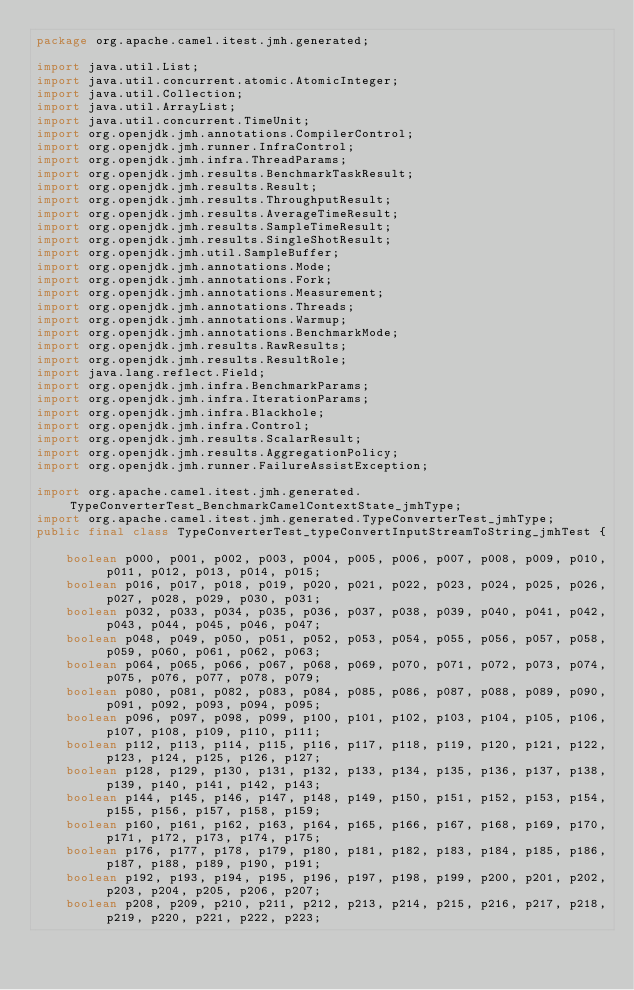Convert code to text. <code><loc_0><loc_0><loc_500><loc_500><_Java_>package org.apache.camel.itest.jmh.generated;

import java.util.List;
import java.util.concurrent.atomic.AtomicInteger;
import java.util.Collection;
import java.util.ArrayList;
import java.util.concurrent.TimeUnit;
import org.openjdk.jmh.annotations.CompilerControl;
import org.openjdk.jmh.runner.InfraControl;
import org.openjdk.jmh.infra.ThreadParams;
import org.openjdk.jmh.results.BenchmarkTaskResult;
import org.openjdk.jmh.results.Result;
import org.openjdk.jmh.results.ThroughputResult;
import org.openjdk.jmh.results.AverageTimeResult;
import org.openjdk.jmh.results.SampleTimeResult;
import org.openjdk.jmh.results.SingleShotResult;
import org.openjdk.jmh.util.SampleBuffer;
import org.openjdk.jmh.annotations.Mode;
import org.openjdk.jmh.annotations.Fork;
import org.openjdk.jmh.annotations.Measurement;
import org.openjdk.jmh.annotations.Threads;
import org.openjdk.jmh.annotations.Warmup;
import org.openjdk.jmh.annotations.BenchmarkMode;
import org.openjdk.jmh.results.RawResults;
import org.openjdk.jmh.results.ResultRole;
import java.lang.reflect.Field;
import org.openjdk.jmh.infra.BenchmarkParams;
import org.openjdk.jmh.infra.IterationParams;
import org.openjdk.jmh.infra.Blackhole;
import org.openjdk.jmh.infra.Control;
import org.openjdk.jmh.results.ScalarResult;
import org.openjdk.jmh.results.AggregationPolicy;
import org.openjdk.jmh.runner.FailureAssistException;

import org.apache.camel.itest.jmh.generated.TypeConverterTest_BenchmarkCamelContextState_jmhType;
import org.apache.camel.itest.jmh.generated.TypeConverterTest_jmhType;
public final class TypeConverterTest_typeConvertInputStreamToString_jmhTest {

    boolean p000, p001, p002, p003, p004, p005, p006, p007, p008, p009, p010, p011, p012, p013, p014, p015;
    boolean p016, p017, p018, p019, p020, p021, p022, p023, p024, p025, p026, p027, p028, p029, p030, p031;
    boolean p032, p033, p034, p035, p036, p037, p038, p039, p040, p041, p042, p043, p044, p045, p046, p047;
    boolean p048, p049, p050, p051, p052, p053, p054, p055, p056, p057, p058, p059, p060, p061, p062, p063;
    boolean p064, p065, p066, p067, p068, p069, p070, p071, p072, p073, p074, p075, p076, p077, p078, p079;
    boolean p080, p081, p082, p083, p084, p085, p086, p087, p088, p089, p090, p091, p092, p093, p094, p095;
    boolean p096, p097, p098, p099, p100, p101, p102, p103, p104, p105, p106, p107, p108, p109, p110, p111;
    boolean p112, p113, p114, p115, p116, p117, p118, p119, p120, p121, p122, p123, p124, p125, p126, p127;
    boolean p128, p129, p130, p131, p132, p133, p134, p135, p136, p137, p138, p139, p140, p141, p142, p143;
    boolean p144, p145, p146, p147, p148, p149, p150, p151, p152, p153, p154, p155, p156, p157, p158, p159;
    boolean p160, p161, p162, p163, p164, p165, p166, p167, p168, p169, p170, p171, p172, p173, p174, p175;
    boolean p176, p177, p178, p179, p180, p181, p182, p183, p184, p185, p186, p187, p188, p189, p190, p191;
    boolean p192, p193, p194, p195, p196, p197, p198, p199, p200, p201, p202, p203, p204, p205, p206, p207;
    boolean p208, p209, p210, p211, p212, p213, p214, p215, p216, p217, p218, p219, p220, p221, p222, p223;</code> 